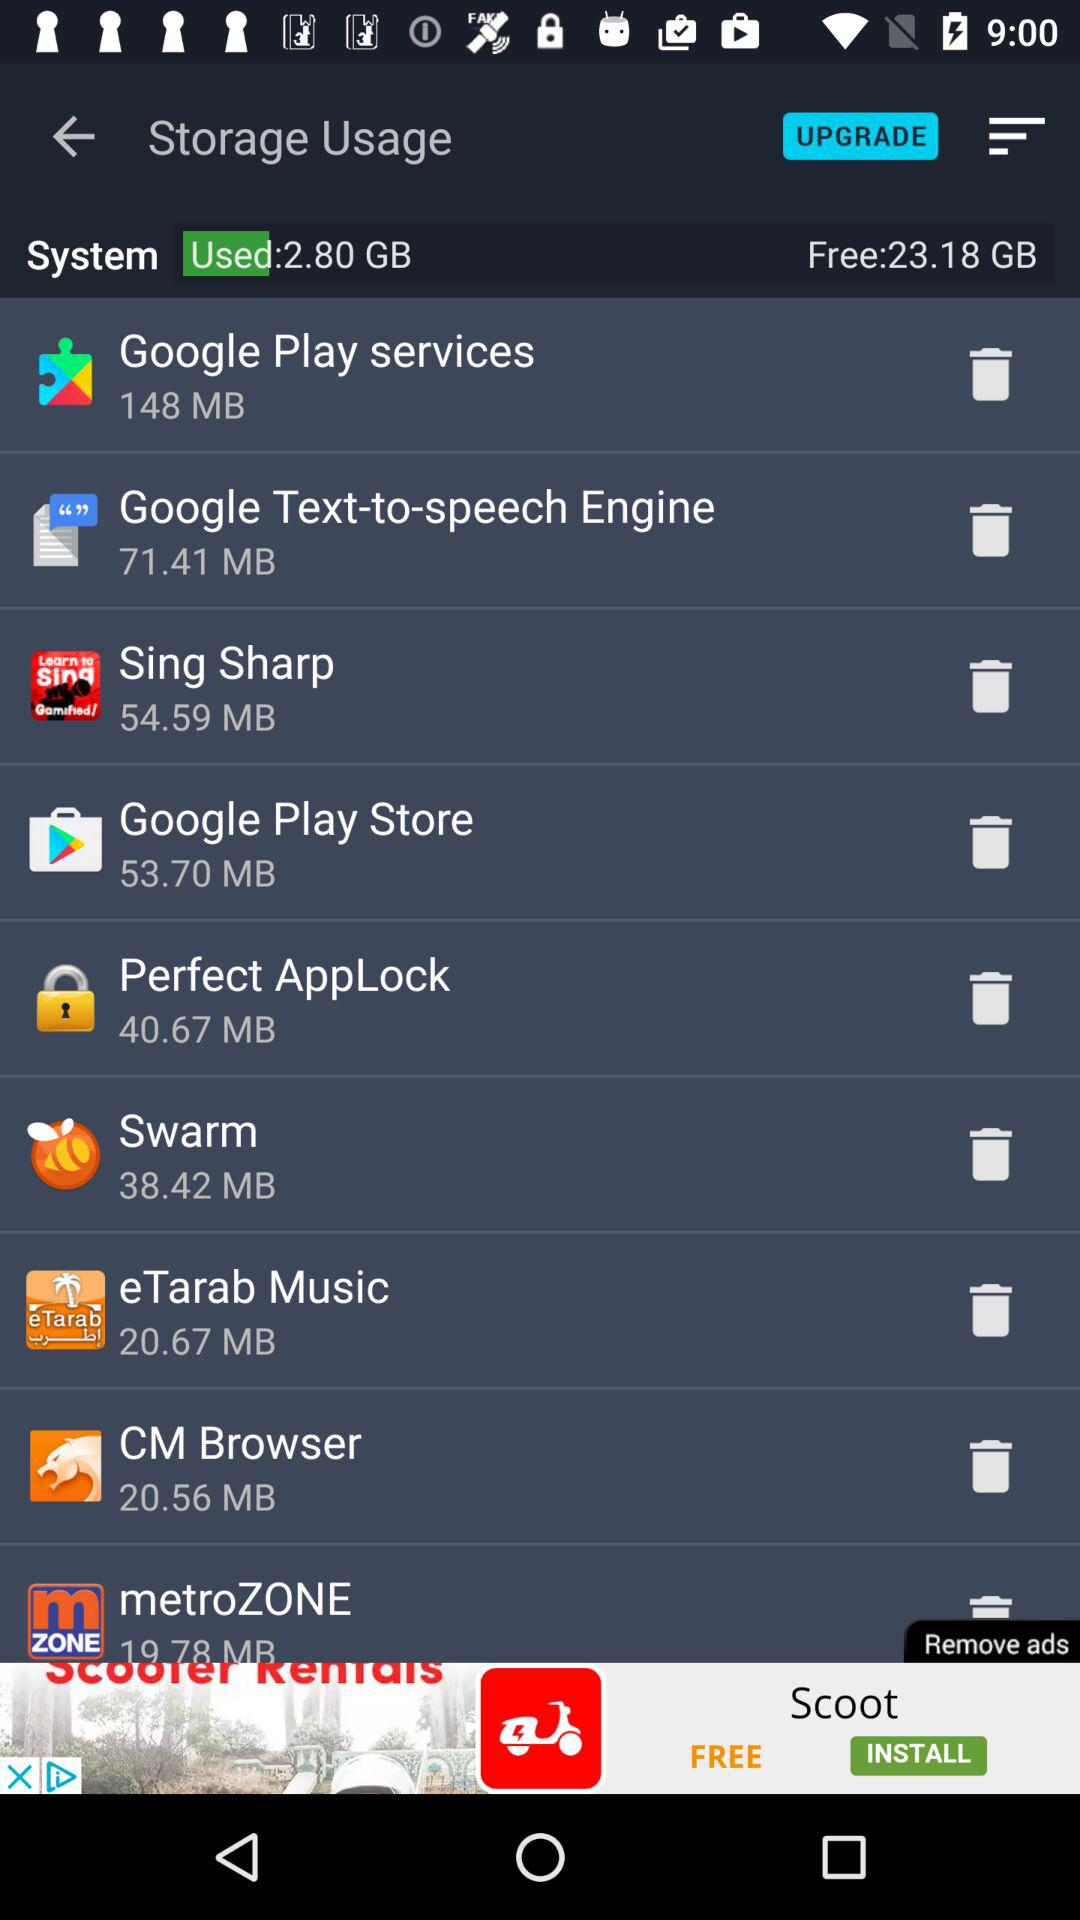How many GB of free storage is there? There is 23.18 GB of free storage. 